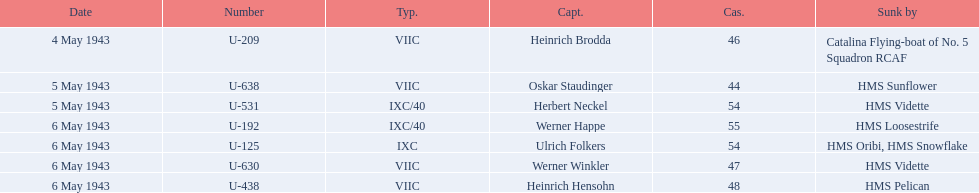Which ship sunk the most u-boats HMS Vidette. 